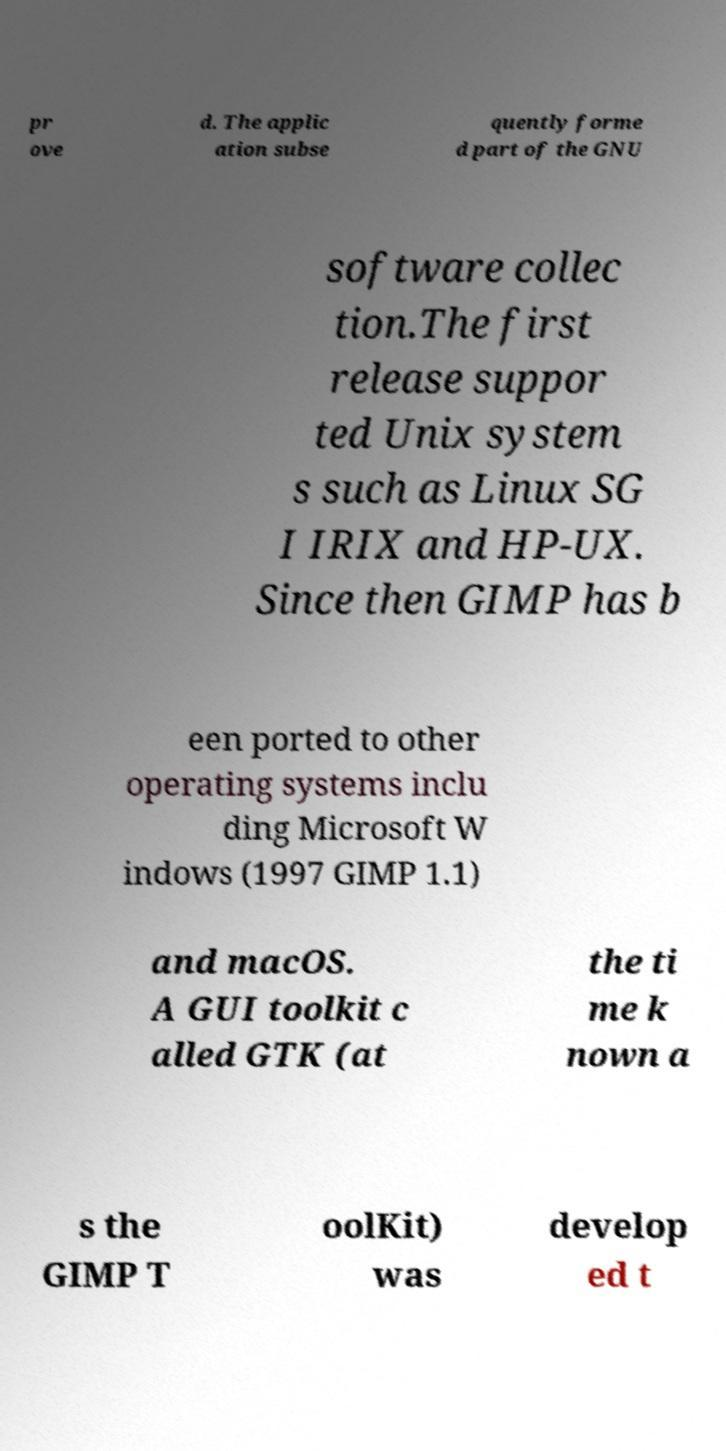Can you read and provide the text displayed in the image?This photo seems to have some interesting text. Can you extract and type it out for me? pr ove d. The applic ation subse quently forme d part of the GNU software collec tion.The first release suppor ted Unix system s such as Linux SG I IRIX and HP-UX. Since then GIMP has b een ported to other operating systems inclu ding Microsoft W indows (1997 GIMP 1.1) and macOS. A GUI toolkit c alled GTK (at the ti me k nown a s the GIMP T oolKit) was develop ed t 